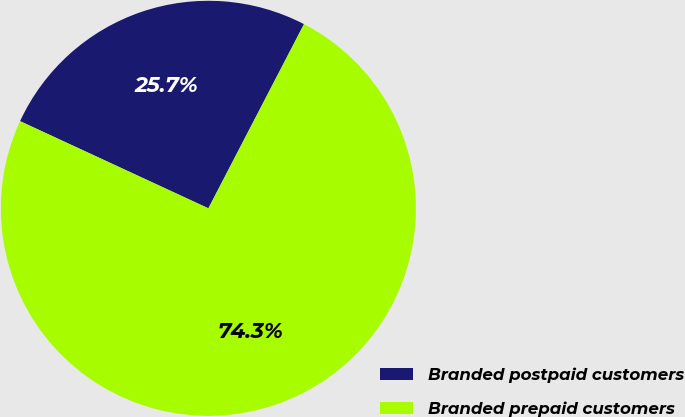Convert chart to OTSL. <chart><loc_0><loc_0><loc_500><loc_500><pie_chart><fcel>Branded postpaid customers<fcel>Branded prepaid customers<nl><fcel>25.72%<fcel>74.28%<nl></chart> 